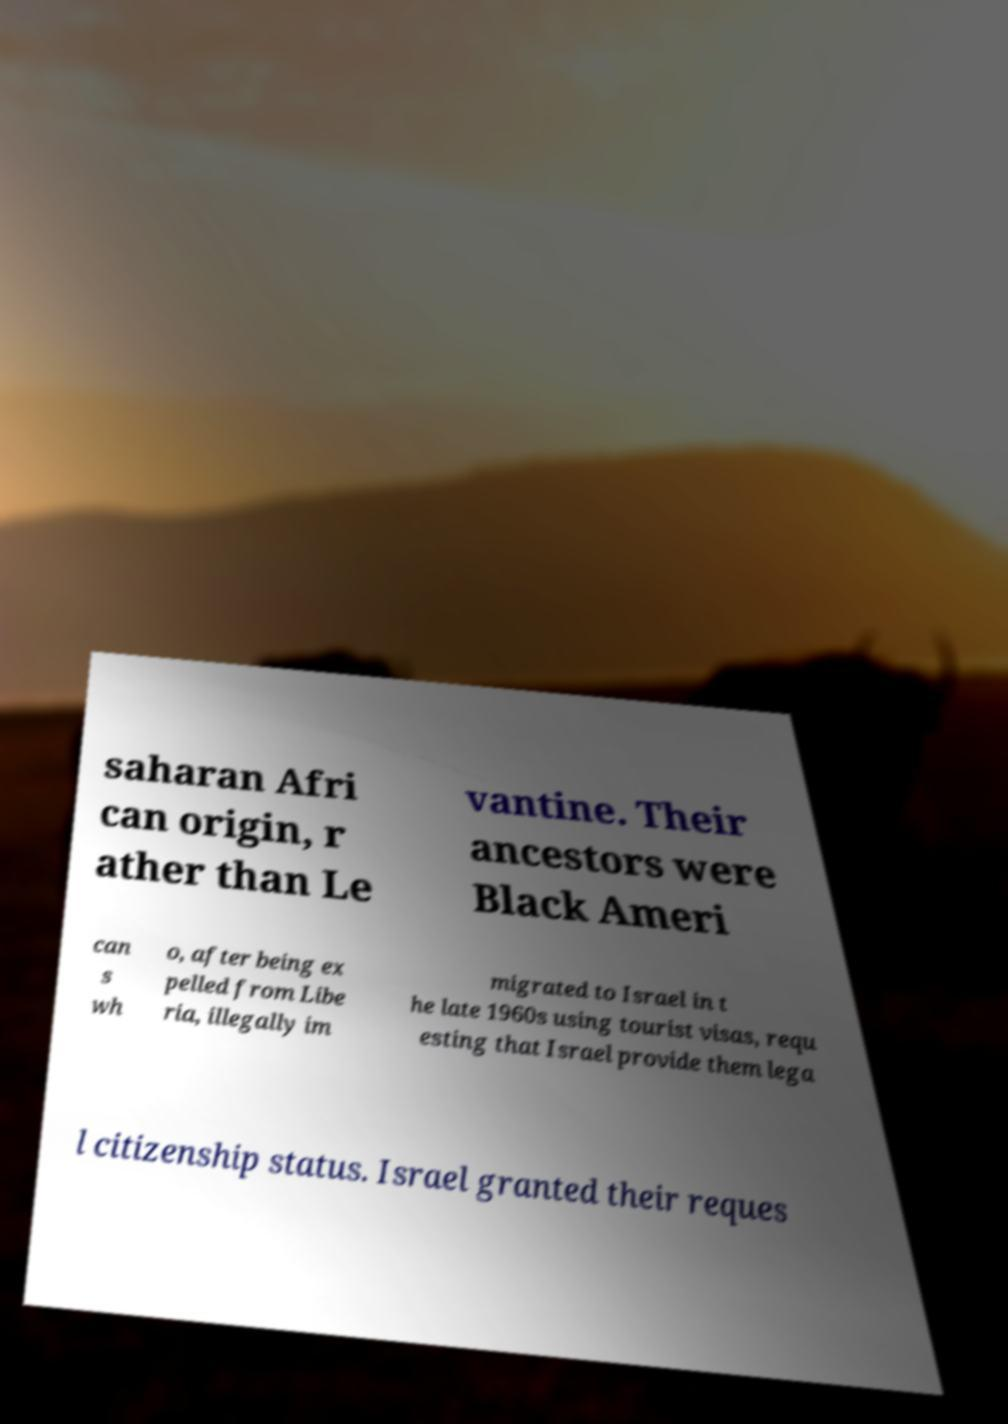Could you extract and type out the text from this image? saharan Afri can origin, r ather than Le vantine. Their ancestors were Black Ameri can s wh o, after being ex pelled from Libe ria, illegally im migrated to Israel in t he late 1960s using tourist visas, requ esting that Israel provide them lega l citizenship status. Israel granted their reques 